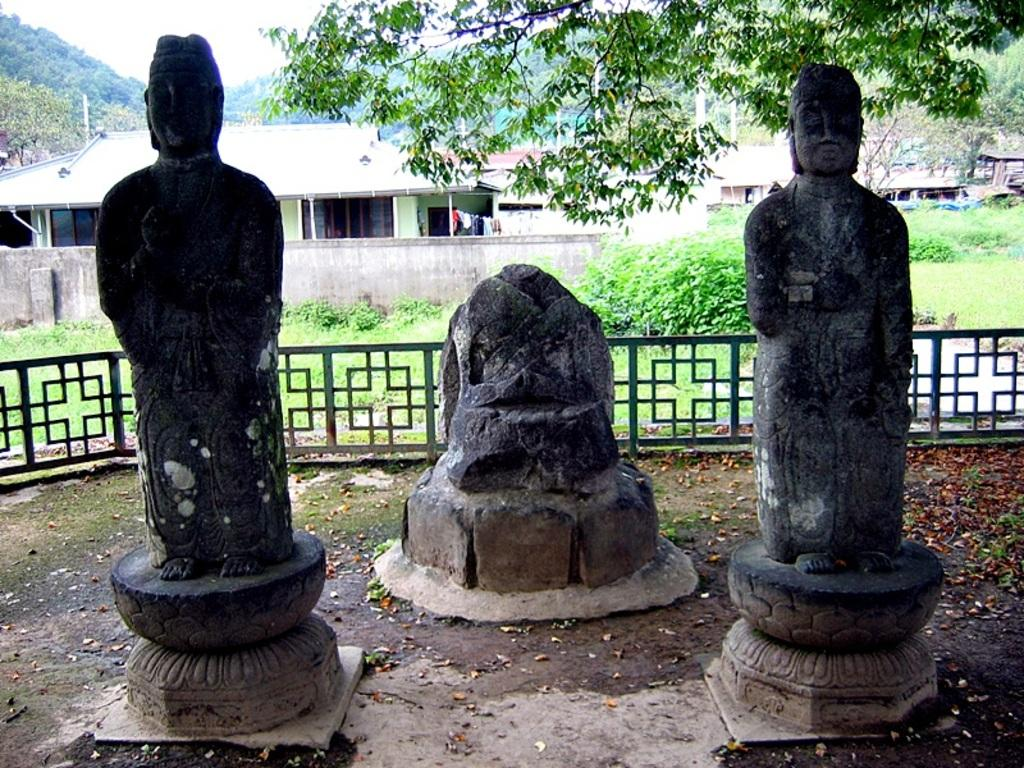How many statues are present in the image? There are three statues in the image. What can be seen in the background of the image? There are houses and trees in the background of the image. What is visible at the top of the image? The sky is visible at the top of the image. What type of dinner is being served to the sheep in the image? There are no sheep or dinner present in the image. How many men are visible in the image? There are no men visible in the image; it only features statues, houses, trees, and the sky. 